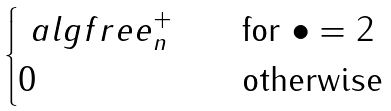<formula> <loc_0><loc_0><loc_500><loc_500>\begin{cases} \ a l g { f r e e } _ { n } ^ { + } & \quad \text {for $\bullet=2$} \\ 0 & \quad \text {otherwise} \end{cases}</formula> 